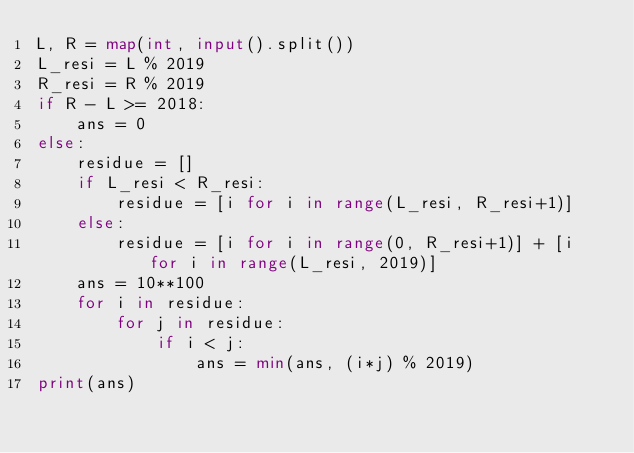<code> <loc_0><loc_0><loc_500><loc_500><_Python_>L, R = map(int, input().split())
L_resi = L % 2019
R_resi = R % 2019
if R - L >= 2018:
    ans = 0
else:
    residue = []
    if L_resi < R_resi:
        residue = [i for i in range(L_resi, R_resi+1)]
    else:
        residue = [i for i in range(0, R_resi+1)] + [i for i in range(L_resi, 2019)]
    ans = 10**100
    for i in residue:
        for j in residue:
            if i < j:
                ans = min(ans, (i*j) % 2019)
print(ans)</code> 